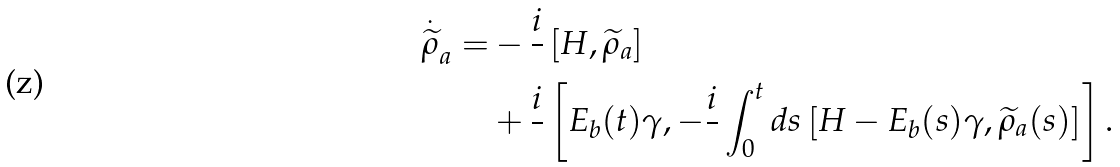<formula> <loc_0><loc_0><loc_500><loc_500>\overset { . } { \widetilde { \rho } } _ { a } = & - \frac { i } { } \left [ H , \widetilde { \rho } _ { a } \right ] \\ & + \frac { i } { } \left [ E _ { b } ( t ) \gamma , - \frac { i } { } \int _ { 0 } ^ { t } d s \left [ H - E _ { b } ( s ) \gamma , \widetilde { \rho } _ { a } ( s ) \right ] \right ] .</formula> 